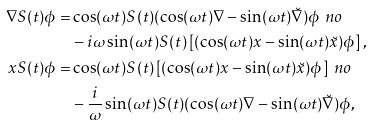<formula> <loc_0><loc_0><loc_500><loc_500>\nabla S ( t ) \phi = & \cos ( \omega t ) S ( t ) ( \cos ( \omega t ) \nabla - \sin ( \omega t ) \breve { \nabla } ) \phi \ n o \\ & - i \omega \sin ( \omega t ) S ( t ) \left [ ( \cos ( \omega t ) x - \sin ( \omega t ) \breve { x } ) \phi \right ] , \\ x S ( t ) \phi = & \cos ( \omega t ) S ( t ) \left [ ( \cos ( \omega t ) x - \sin ( \omega t ) \breve { x } ) \phi \right ] \ n o \\ & - \frac { i } { \omega } \sin ( \omega t ) S ( t ) ( \cos ( \omega t ) \nabla - \sin ( \omega t ) \breve { \nabla } ) \phi ,</formula> 